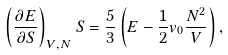Convert formula to latex. <formula><loc_0><loc_0><loc_500><loc_500>\left ( \frac { \partial E } { \partial S } \right ) _ { V , N } S = \frac { 5 } { 3 } \left ( E - \frac { 1 } { 2 } v _ { 0 } \frac { N ^ { 2 } } { V } \right ) ,</formula> 